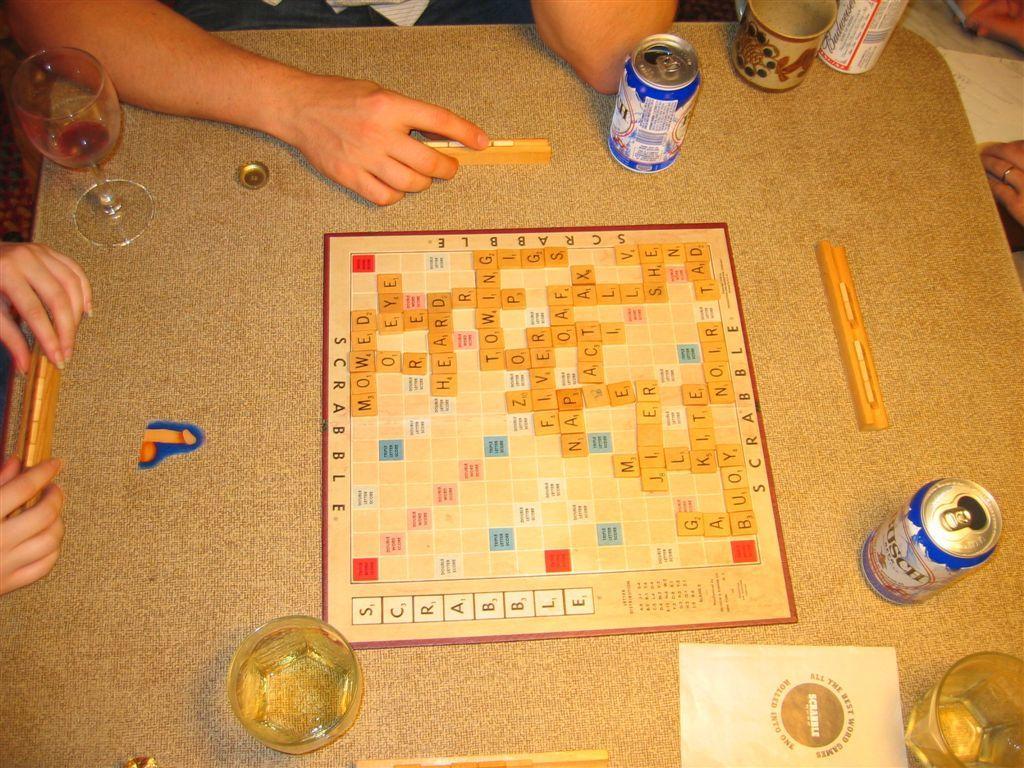In one or two sentences, can you explain what this image depicts? In this picture there is a table which has few glasses of drinks and some other objects on it and there are few persons holding an object which is placed on the table. 